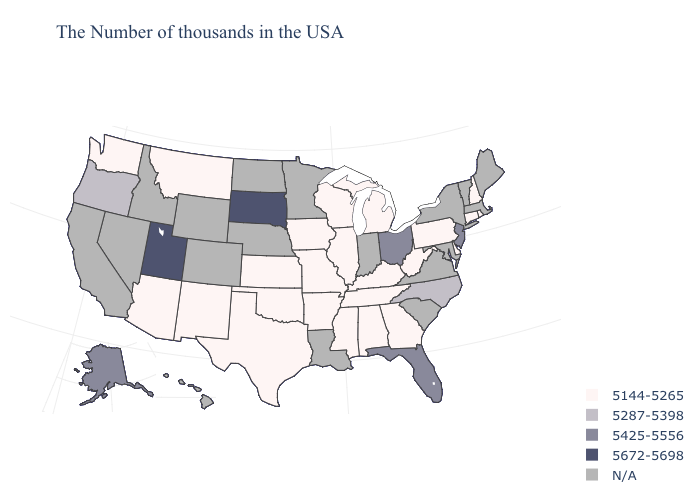Name the states that have a value in the range 5672-5698?
Short answer required. South Dakota, Utah. Is the legend a continuous bar?
Concise answer only. No. What is the highest value in the South ?
Keep it brief. 5425-5556. What is the highest value in the West ?
Answer briefly. 5672-5698. How many symbols are there in the legend?
Concise answer only. 5. Name the states that have a value in the range 5144-5265?
Quick response, please. Rhode Island, New Hampshire, Connecticut, Delaware, Pennsylvania, West Virginia, Georgia, Michigan, Kentucky, Alabama, Tennessee, Wisconsin, Illinois, Mississippi, Missouri, Arkansas, Iowa, Kansas, Oklahoma, Texas, New Mexico, Montana, Arizona, Washington. Which states hav the highest value in the Northeast?
Short answer required. New Jersey. Does Wisconsin have the lowest value in the USA?
Keep it brief. Yes. Name the states that have a value in the range 5144-5265?
Quick response, please. Rhode Island, New Hampshire, Connecticut, Delaware, Pennsylvania, West Virginia, Georgia, Michigan, Kentucky, Alabama, Tennessee, Wisconsin, Illinois, Mississippi, Missouri, Arkansas, Iowa, Kansas, Oklahoma, Texas, New Mexico, Montana, Arizona, Washington. Name the states that have a value in the range N/A?
Be succinct. Maine, Massachusetts, Vermont, New York, Maryland, Virginia, South Carolina, Indiana, Louisiana, Minnesota, Nebraska, North Dakota, Wyoming, Colorado, Idaho, Nevada, California, Hawaii. What is the value of Colorado?
Keep it brief. N/A. What is the lowest value in the USA?
Quick response, please. 5144-5265. 